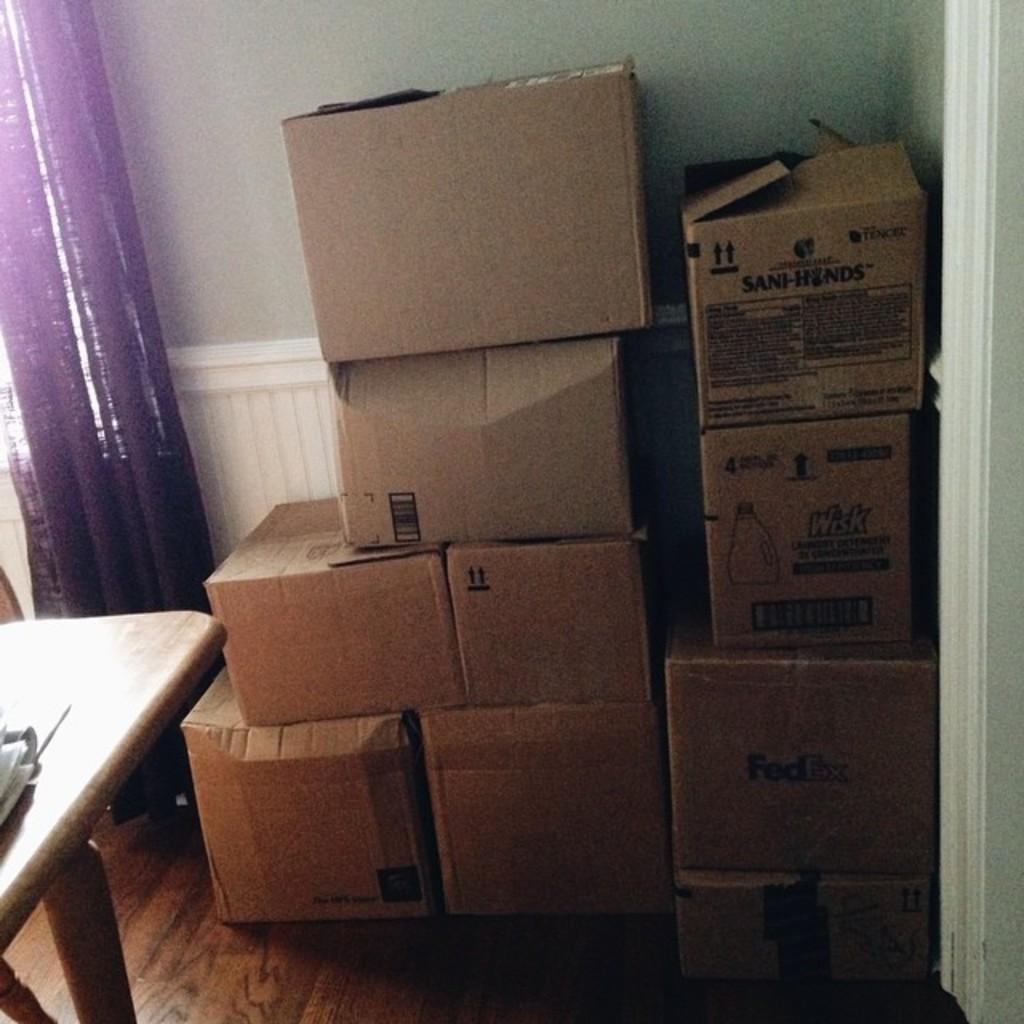Where was the image taken? The image was taken in a room. What can be seen in the center of the image? There are cardboard boxes in the center of the image. What is located on the left side of the image? There is a table on the left side of the image. What can be seen in the background of the image? There is a curtain and a wall in the background of the image. What type of creature can be seen crawling on the cardboard boxes in the image? There are no creatures visible in the image; it only shows cardboard boxes, a table, and background elements. 